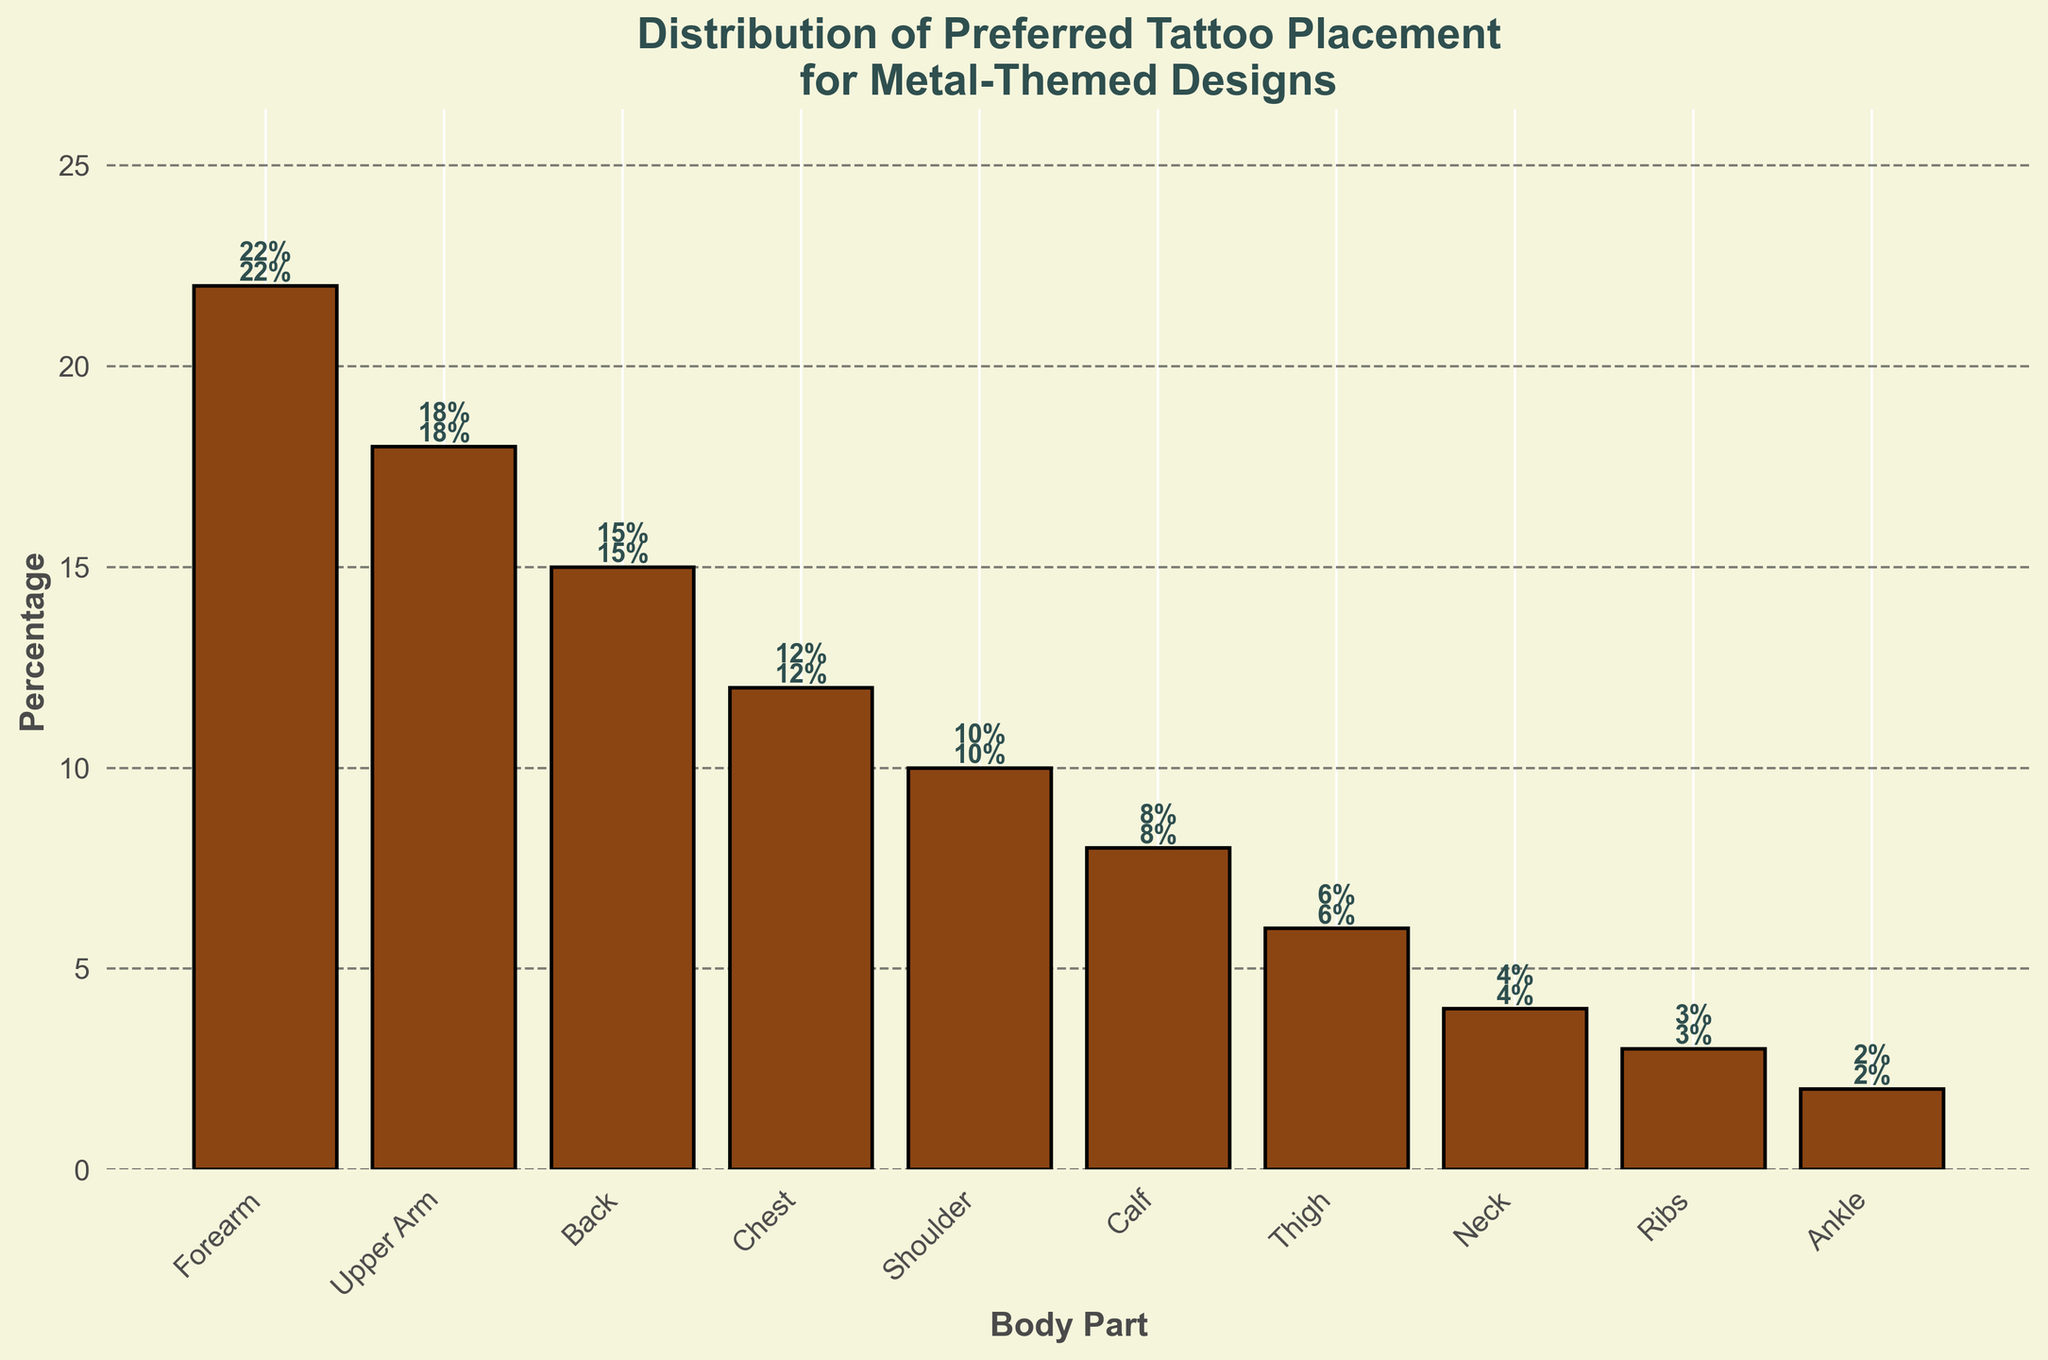What is the most preferred body part for metal-themed tattoo placement? The bar chart shows the highest percentage for the "Forearm" body part.
Answer: Forearm How many body parts have a placement percentage of more than 10%? According to the bar chart, the body parts with more than 10% placement are Forearm, Upper Arm, Back, Chest, and Shoulder. Counting these gives us 5.
Answer: 5 Which two body parts have the smallest difference in their tattoo placement percentages? The closest percentages between any two body parts are between "Thigh" (6%) and "Neck" (4%). Calculating the absolute difference, we get
Answer: Thigh and Neck What is the combined percentage for chest and shoulder placements? Adding the percentage for the chest (12%) and the shoulder (10%), we get 12% + 10% = 22%.
Answer: 22% By how much does the calf tattoo placement percentage exceed the tattoo placement percentage around the neck? According to the bar chart, the calf placement is 8% and the neck placement is 4%. So, 8% - 4% = 4%.
Answer: 4% Compare the placement of tattoos on the ribs and thigh. Which one is higher, and by what percentage? The bar chart shows that the thigh placement is 6% and the ribs placement is 3%. Therefore, the thigh placement is higher by 6% - 3% = 3%.
Answer: Thigh, by 3% What percentage of placements does the least preferred body part have? The least preferred body part according to the chart is the "Ankle" with a 2% placement.
Answer: 2% What is the average tattoo placement percentage across all the body parts? The sum of percentages for all body parts is 22 + 18 + 15 + 12 + 10 + 8 + 6 + 4 + 3 + 2 = 100. There are 10 body parts. So, the average is 100 / 10 = 10%.
Answer: 10% By how much does the collective placement percentage of forearm and upper arm surpass the percentage of back and chest placements combined? Forearm and upper arm have combined placements of 22% + 18% = 40%. Back and chest together have 15% + 12% = 27%. The difference is 40% - 27% = 13%.
Answer: 13% Which body part is preferred more for tattoos: upper arm or back? The bar chart indicates that the upper arm has a higher percentage (18%) compared to the back (15%).
Answer: Upper Arm 